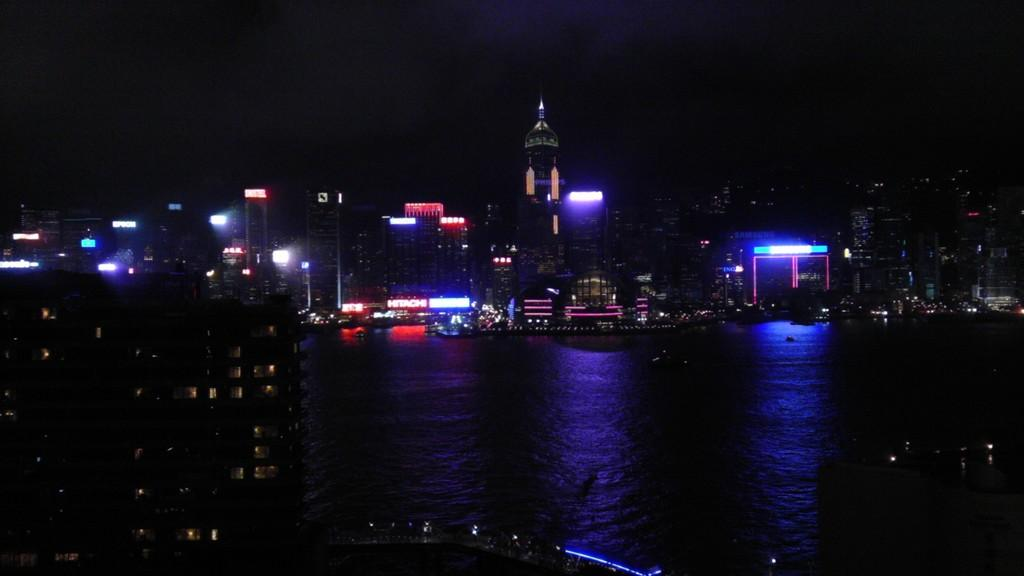What is the time of day depicted in the image? The image is a night view of a city. What natural feature can be seen in the image? There is a river in the image. What type of structures are visible in the background? There are buildings in the background of the image. Where can the beggar be seen in the image? There is no beggar present in the image. What type of drink is being served at the riverside in the image? There is no drink or any indication of a drink being served in the image. 